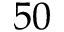Convert formula to latex. <formula><loc_0><loc_0><loc_500><loc_500>5 0</formula> 